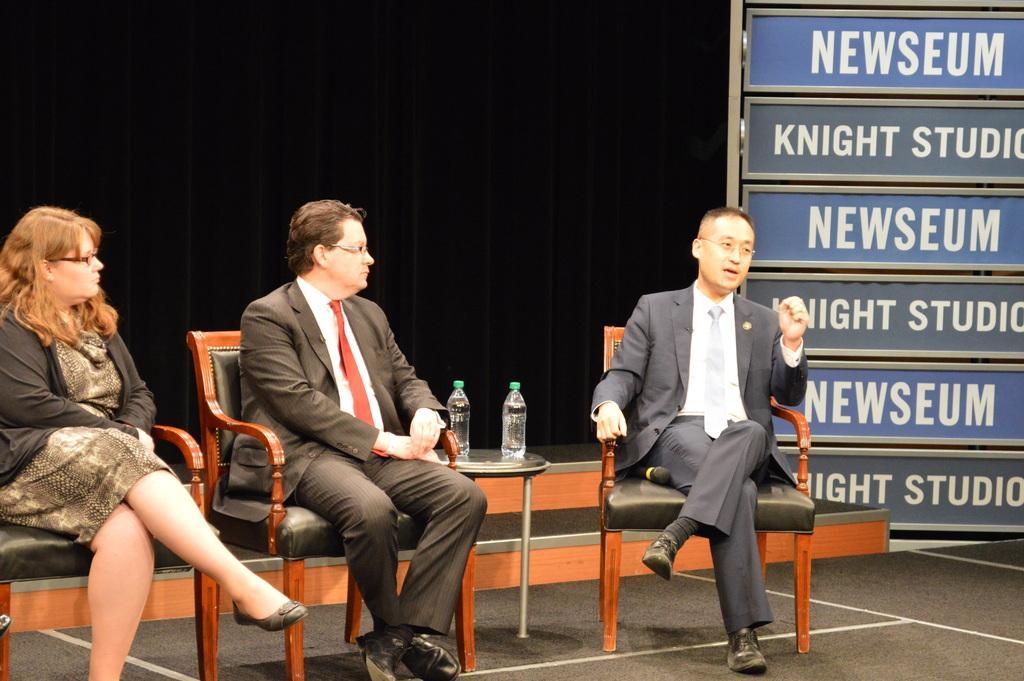In one or two sentences, can you explain what this image depicts? In this picture I can see a woman and 2 men sitting on chairs and I see a stool on which there are 2 bottles. On the right side of this image, I can see the boards on which I see something is written and I see the black color background. 